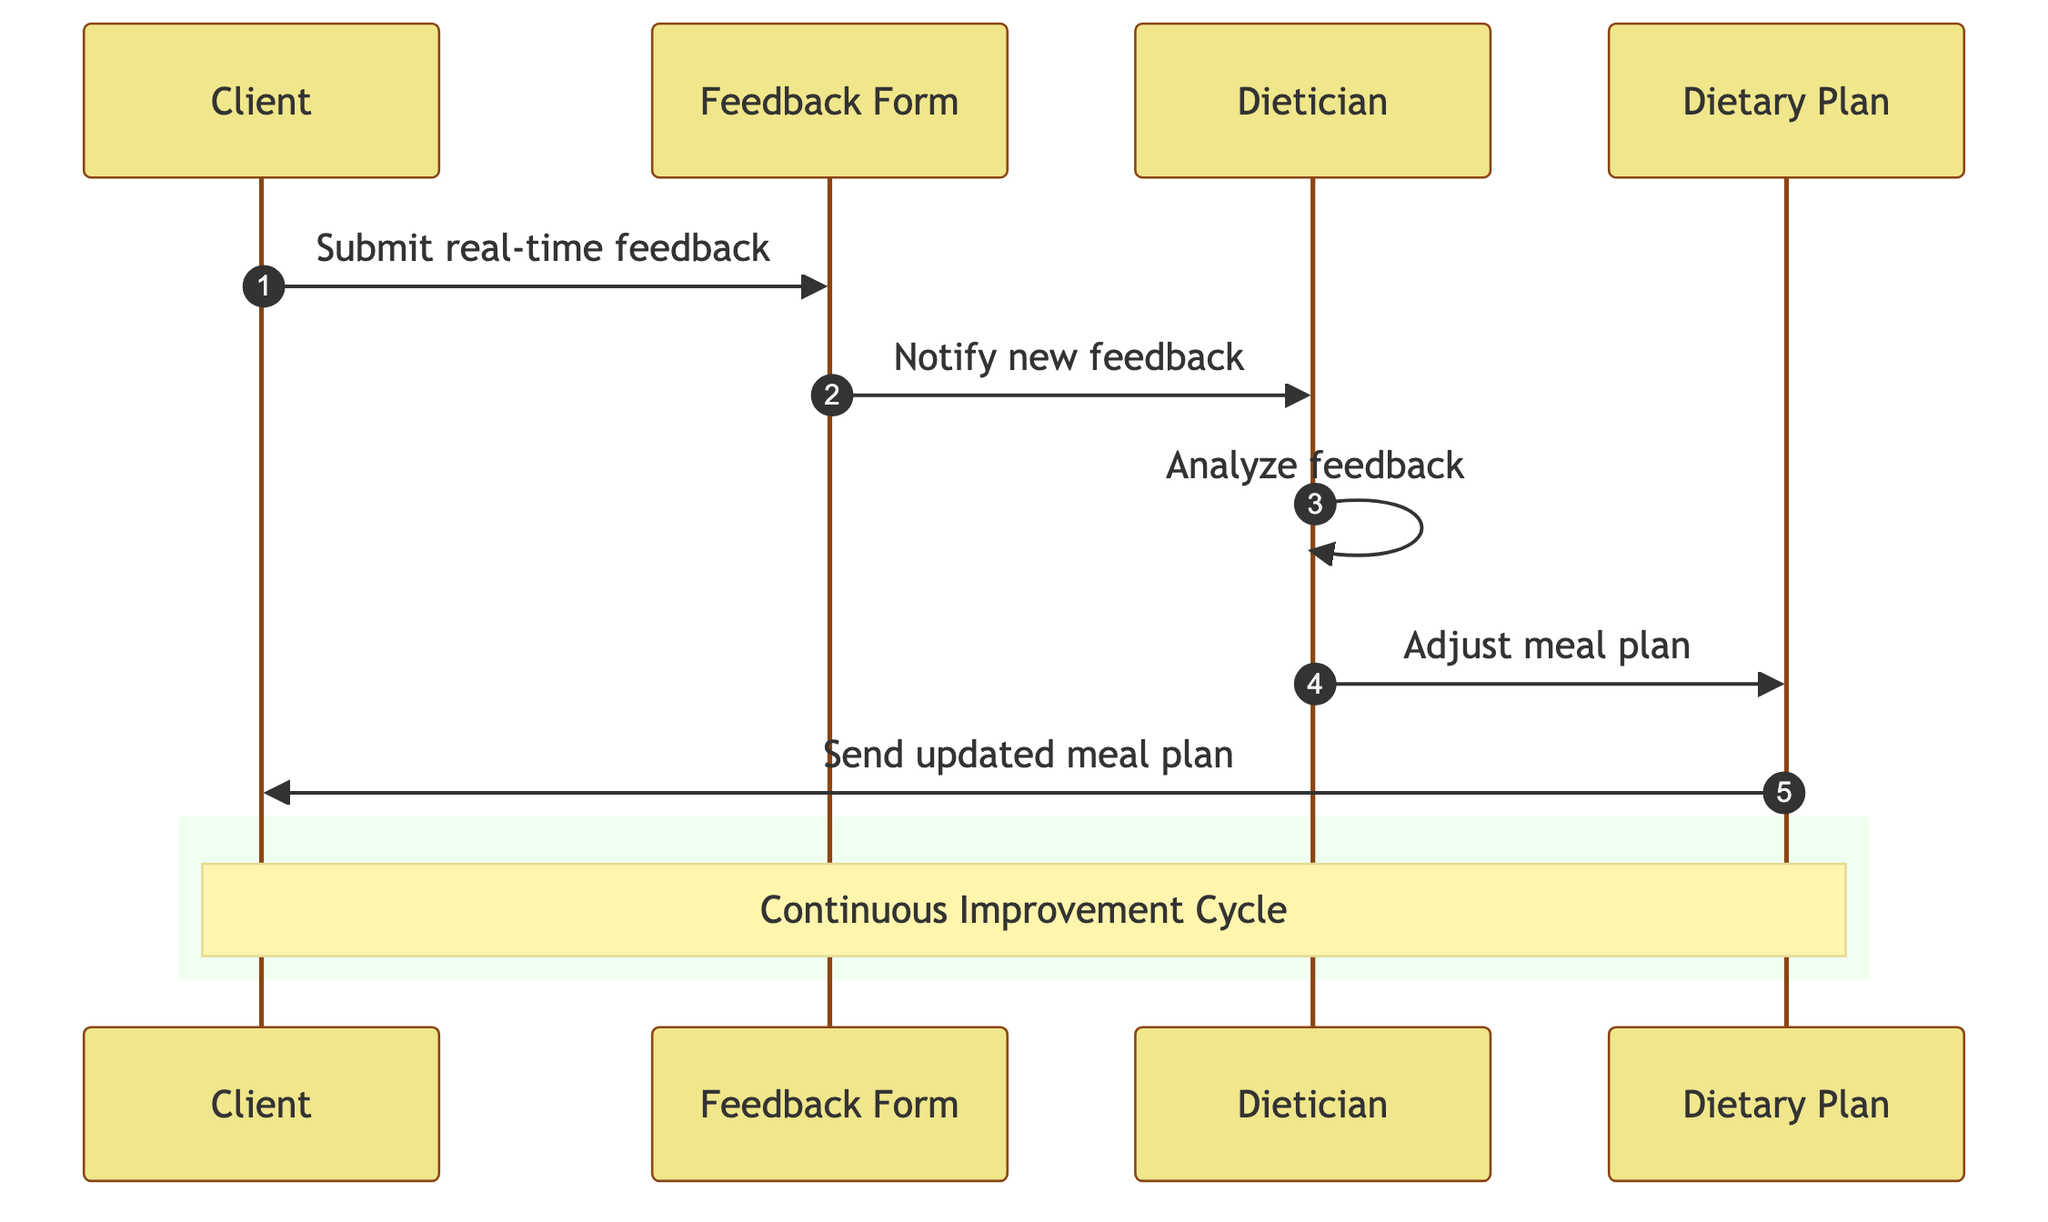What is the first action taken by the Client? The diagram starts with the Client initiating the process by submitting real-time feedback, which is the first action depicted.
Answer: Submit real-time feedback How many actors are present in the diagram? There are four entities represented in the diagram: Client, Dietician, Dietary Plan, and Feedback Form. Thus, the total count of actors is four.
Answer: Four What feedback does the Feedback Form provide to the Dietician? The Feedback Form serves as a communication medium that notifies the Dietician when new feedback has been submitted by the Client.
Answer: Notify new feedback What does the Dietician do after analyzing the feedback? Upon analyzing the feedback, the Dietician takes the necessary steps to adjust the meal plan based on the insights gathered from the feedback.
Answer: Adjust meal plan What is sent to the Client after the meal plan is updated? Once the dietary adjustments are made, the updated meal plan is sent back to the Client as a response to the adjustments made.
Answer: Send updated meal plan How does the process contribute to continuous improvement? The flow from Client's feedback to dietary adjustments illustrates an iterative cycle, suggesting that feedback and adjustments will continuously refine the meal planning process over time.
Answer: Continuous Improvement Cycle What is the role of the Dietary Plan in this process? The Dietary Plan acts as an object that is modified by the Dietician based on the feedback received from the Client, serving as the output of the process.
Answer: Customized heart-healthy meal plan Which action comes immediately after the notification from the Feedback Form? The immediate action following the notification from the Feedback Form is for the Dietician to analyze the feedback in order to understand the client's needs better.
Answer: Analyze feedback What does the note in the rectangle indicate about the process? The note within the rectangle highlights that the overall process is part of a Continuous Improvement Cycle, emphasizing ongoing adaptation and refinement based on client feedback.
Answer: Continuous Improvement Cycle 